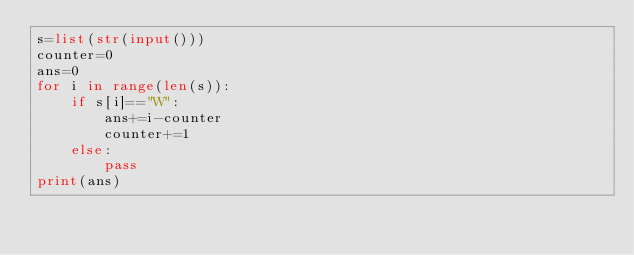<code> <loc_0><loc_0><loc_500><loc_500><_Python_>s=list(str(input()))
counter=0
ans=0
for i in range(len(s)):
    if s[i]=="W":
        ans+=i-counter
        counter+=1
    else:
        pass
print(ans)
</code> 